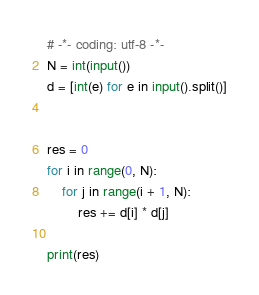Convert code to text. <code><loc_0><loc_0><loc_500><loc_500><_Python_># -*- coding: utf-8 -*-
N = int(input())
d = [int(e) for e in input().split()]


res = 0
for i in range(0, N):
	for j in range(i + 1, N):
		res += d[i] * d[j]

print(res)
</code> 